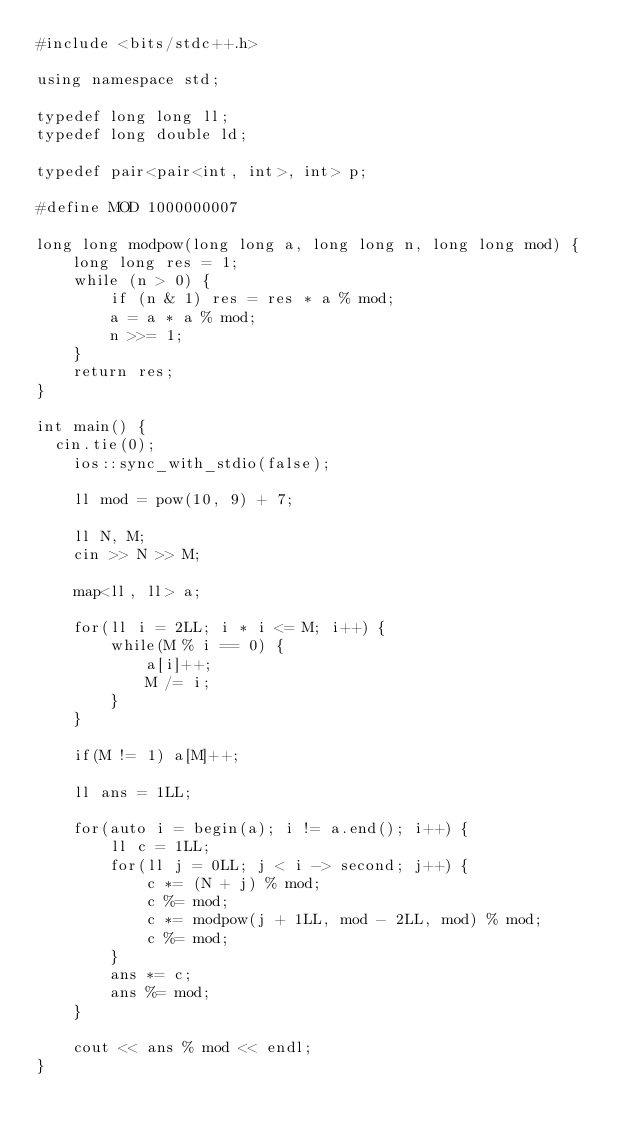Convert code to text. <code><loc_0><loc_0><loc_500><loc_500><_C++_>#include <bits/stdc++.h>
 
using namespace std;
 
typedef long long ll;
typedef long double ld;
 
typedef pair<pair<int, int>, int> p;

#define MOD 1000000007

long long modpow(long long a, long long n, long long mod) {
    long long res = 1;
    while (n > 0) {
        if (n & 1) res = res * a % mod;
        a = a * a % mod;
        n >>= 1;
    }
    return res;
}

int main() {
	cin.tie(0);
    ios::sync_with_stdio(false);

    ll mod = pow(10, 9) + 7;

    ll N, M;
    cin >> N >> M;

    map<ll, ll> a;

    for(ll i = 2LL; i * i <= M; i++) {
        while(M % i == 0) {
            a[i]++;
            M /= i;
        }
    }

    if(M != 1) a[M]++;

    ll ans = 1LL;

    for(auto i = begin(a); i != a.end(); i++) {
        ll c = 1LL;
        for(ll j = 0LL; j < i -> second; j++) {
            c *= (N + j) % mod;
            c %= mod;
            c *= modpow(j + 1LL, mod - 2LL, mod) % mod;
            c %= mod;
        }
        ans *= c;
        ans %= mod;
    }

    cout << ans % mod << endl;
}</code> 